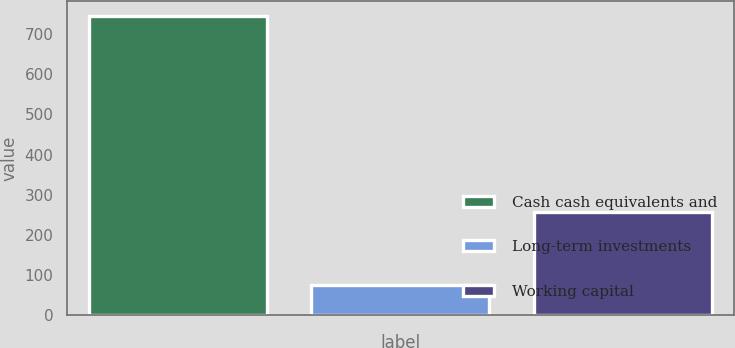Convert chart. <chart><loc_0><loc_0><loc_500><loc_500><bar_chart><fcel>Cash cash equivalents and<fcel>Long-term investments<fcel>Working capital<nl><fcel>744<fcel>75<fcel>258<nl></chart> 